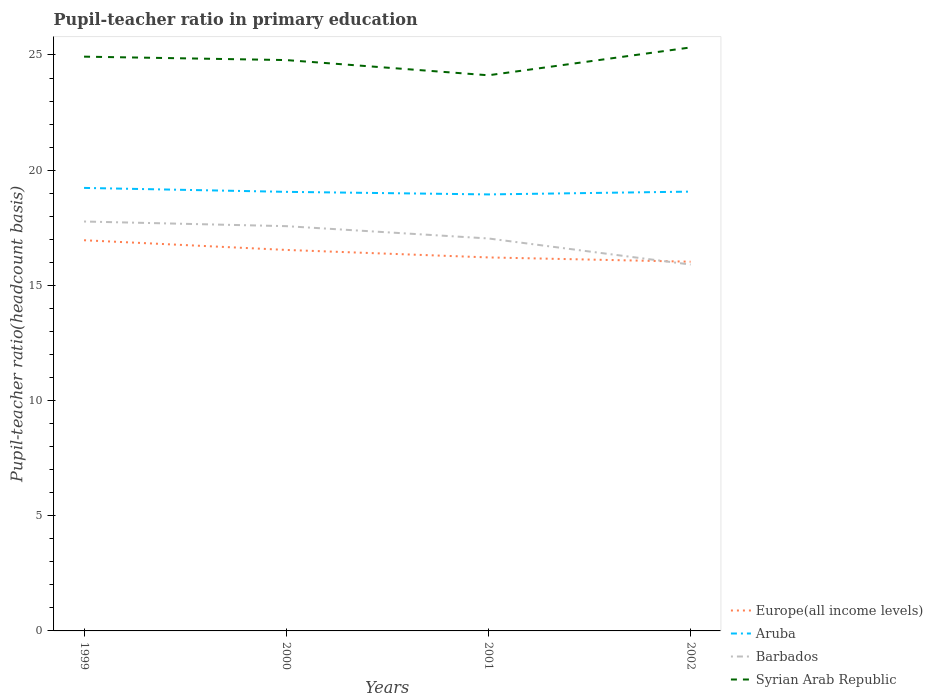How many different coloured lines are there?
Provide a short and direct response. 4. Across all years, what is the maximum pupil-teacher ratio in primary education in Europe(all income levels)?
Ensure brevity in your answer.  16.03. In which year was the pupil-teacher ratio in primary education in Aruba maximum?
Provide a succinct answer. 2001. What is the total pupil-teacher ratio in primary education in Barbados in the graph?
Ensure brevity in your answer.  1.67. What is the difference between the highest and the second highest pupil-teacher ratio in primary education in Syrian Arab Republic?
Provide a short and direct response. 1.21. What is the difference between the highest and the lowest pupil-teacher ratio in primary education in Syrian Arab Republic?
Make the answer very short. 2. How many years are there in the graph?
Make the answer very short. 4. Are the values on the major ticks of Y-axis written in scientific E-notation?
Keep it short and to the point. No. Does the graph contain grids?
Give a very brief answer. No. Where does the legend appear in the graph?
Offer a terse response. Bottom right. How are the legend labels stacked?
Ensure brevity in your answer.  Vertical. What is the title of the graph?
Give a very brief answer. Pupil-teacher ratio in primary education. What is the label or title of the Y-axis?
Offer a terse response. Pupil-teacher ratio(headcount basis). What is the Pupil-teacher ratio(headcount basis) in Europe(all income levels) in 1999?
Give a very brief answer. 16.96. What is the Pupil-teacher ratio(headcount basis) of Aruba in 1999?
Keep it short and to the point. 19.23. What is the Pupil-teacher ratio(headcount basis) of Barbados in 1999?
Your response must be concise. 17.77. What is the Pupil-teacher ratio(headcount basis) in Syrian Arab Republic in 1999?
Your response must be concise. 24.93. What is the Pupil-teacher ratio(headcount basis) in Europe(all income levels) in 2000?
Your response must be concise. 16.54. What is the Pupil-teacher ratio(headcount basis) of Aruba in 2000?
Provide a short and direct response. 19.06. What is the Pupil-teacher ratio(headcount basis) in Barbados in 2000?
Your answer should be very brief. 17.57. What is the Pupil-teacher ratio(headcount basis) of Syrian Arab Republic in 2000?
Make the answer very short. 24.78. What is the Pupil-teacher ratio(headcount basis) of Europe(all income levels) in 2001?
Provide a short and direct response. 16.21. What is the Pupil-teacher ratio(headcount basis) of Aruba in 2001?
Offer a terse response. 18.95. What is the Pupil-teacher ratio(headcount basis) in Barbados in 2001?
Your response must be concise. 17.04. What is the Pupil-teacher ratio(headcount basis) of Syrian Arab Republic in 2001?
Offer a terse response. 24.12. What is the Pupil-teacher ratio(headcount basis) of Europe(all income levels) in 2002?
Provide a short and direct response. 16.03. What is the Pupil-teacher ratio(headcount basis) in Aruba in 2002?
Keep it short and to the point. 19.07. What is the Pupil-teacher ratio(headcount basis) of Barbados in 2002?
Offer a terse response. 15.9. What is the Pupil-teacher ratio(headcount basis) in Syrian Arab Republic in 2002?
Your answer should be compact. 25.33. Across all years, what is the maximum Pupil-teacher ratio(headcount basis) in Europe(all income levels)?
Provide a short and direct response. 16.96. Across all years, what is the maximum Pupil-teacher ratio(headcount basis) in Aruba?
Your answer should be very brief. 19.23. Across all years, what is the maximum Pupil-teacher ratio(headcount basis) of Barbados?
Your answer should be very brief. 17.77. Across all years, what is the maximum Pupil-teacher ratio(headcount basis) in Syrian Arab Republic?
Your answer should be very brief. 25.33. Across all years, what is the minimum Pupil-teacher ratio(headcount basis) in Europe(all income levels)?
Make the answer very short. 16.03. Across all years, what is the minimum Pupil-teacher ratio(headcount basis) in Aruba?
Give a very brief answer. 18.95. Across all years, what is the minimum Pupil-teacher ratio(headcount basis) of Barbados?
Offer a very short reply. 15.9. Across all years, what is the minimum Pupil-teacher ratio(headcount basis) of Syrian Arab Republic?
Keep it short and to the point. 24.12. What is the total Pupil-teacher ratio(headcount basis) in Europe(all income levels) in the graph?
Ensure brevity in your answer.  65.74. What is the total Pupil-teacher ratio(headcount basis) of Aruba in the graph?
Your answer should be compact. 76.31. What is the total Pupil-teacher ratio(headcount basis) in Barbados in the graph?
Provide a short and direct response. 68.28. What is the total Pupil-teacher ratio(headcount basis) of Syrian Arab Republic in the graph?
Provide a succinct answer. 99.16. What is the difference between the Pupil-teacher ratio(headcount basis) of Europe(all income levels) in 1999 and that in 2000?
Provide a short and direct response. 0.42. What is the difference between the Pupil-teacher ratio(headcount basis) of Aruba in 1999 and that in 2000?
Provide a short and direct response. 0.17. What is the difference between the Pupil-teacher ratio(headcount basis) of Barbados in 1999 and that in 2000?
Make the answer very short. 0.2. What is the difference between the Pupil-teacher ratio(headcount basis) in Syrian Arab Republic in 1999 and that in 2000?
Offer a terse response. 0.15. What is the difference between the Pupil-teacher ratio(headcount basis) in Europe(all income levels) in 1999 and that in 2001?
Offer a very short reply. 0.75. What is the difference between the Pupil-teacher ratio(headcount basis) of Aruba in 1999 and that in 2001?
Keep it short and to the point. 0.28. What is the difference between the Pupil-teacher ratio(headcount basis) in Barbados in 1999 and that in 2001?
Give a very brief answer. 0.74. What is the difference between the Pupil-teacher ratio(headcount basis) in Syrian Arab Republic in 1999 and that in 2001?
Your answer should be compact. 0.81. What is the difference between the Pupil-teacher ratio(headcount basis) of Europe(all income levels) in 1999 and that in 2002?
Your answer should be very brief. 0.93. What is the difference between the Pupil-teacher ratio(headcount basis) of Aruba in 1999 and that in 2002?
Give a very brief answer. 0.16. What is the difference between the Pupil-teacher ratio(headcount basis) in Barbados in 1999 and that in 2002?
Your response must be concise. 1.87. What is the difference between the Pupil-teacher ratio(headcount basis) of Syrian Arab Republic in 1999 and that in 2002?
Your response must be concise. -0.4. What is the difference between the Pupil-teacher ratio(headcount basis) of Europe(all income levels) in 2000 and that in 2001?
Your answer should be very brief. 0.32. What is the difference between the Pupil-teacher ratio(headcount basis) in Aruba in 2000 and that in 2001?
Your answer should be compact. 0.11. What is the difference between the Pupil-teacher ratio(headcount basis) of Barbados in 2000 and that in 2001?
Ensure brevity in your answer.  0.53. What is the difference between the Pupil-teacher ratio(headcount basis) in Syrian Arab Republic in 2000 and that in 2001?
Give a very brief answer. 0.66. What is the difference between the Pupil-teacher ratio(headcount basis) of Europe(all income levels) in 2000 and that in 2002?
Your answer should be very brief. 0.51. What is the difference between the Pupil-teacher ratio(headcount basis) in Aruba in 2000 and that in 2002?
Your answer should be very brief. -0.01. What is the difference between the Pupil-teacher ratio(headcount basis) of Barbados in 2000 and that in 2002?
Ensure brevity in your answer.  1.67. What is the difference between the Pupil-teacher ratio(headcount basis) of Syrian Arab Republic in 2000 and that in 2002?
Your answer should be compact. -0.55. What is the difference between the Pupil-teacher ratio(headcount basis) in Europe(all income levels) in 2001 and that in 2002?
Provide a short and direct response. 0.19. What is the difference between the Pupil-teacher ratio(headcount basis) in Aruba in 2001 and that in 2002?
Your answer should be compact. -0.12. What is the difference between the Pupil-teacher ratio(headcount basis) in Barbados in 2001 and that in 2002?
Provide a succinct answer. 1.13. What is the difference between the Pupil-teacher ratio(headcount basis) in Syrian Arab Republic in 2001 and that in 2002?
Your answer should be very brief. -1.21. What is the difference between the Pupil-teacher ratio(headcount basis) of Europe(all income levels) in 1999 and the Pupil-teacher ratio(headcount basis) of Aruba in 2000?
Give a very brief answer. -2.1. What is the difference between the Pupil-teacher ratio(headcount basis) of Europe(all income levels) in 1999 and the Pupil-teacher ratio(headcount basis) of Barbados in 2000?
Offer a very short reply. -0.61. What is the difference between the Pupil-teacher ratio(headcount basis) of Europe(all income levels) in 1999 and the Pupil-teacher ratio(headcount basis) of Syrian Arab Republic in 2000?
Make the answer very short. -7.82. What is the difference between the Pupil-teacher ratio(headcount basis) of Aruba in 1999 and the Pupil-teacher ratio(headcount basis) of Barbados in 2000?
Offer a very short reply. 1.66. What is the difference between the Pupil-teacher ratio(headcount basis) in Aruba in 1999 and the Pupil-teacher ratio(headcount basis) in Syrian Arab Republic in 2000?
Ensure brevity in your answer.  -5.55. What is the difference between the Pupil-teacher ratio(headcount basis) in Barbados in 1999 and the Pupil-teacher ratio(headcount basis) in Syrian Arab Republic in 2000?
Ensure brevity in your answer.  -7.01. What is the difference between the Pupil-teacher ratio(headcount basis) of Europe(all income levels) in 1999 and the Pupil-teacher ratio(headcount basis) of Aruba in 2001?
Your answer should be compact. -1.99. What is the difference between the Pupil-teacher ratio(headcount basis) in Europe(all income levels) in 1999 and the Pupil-teacher ratio(headcount basis) in Barbados in 2001?
Your response must be concise. -0.08. What is the difference between the Pupil-teacher ratio(headcount basis) of Europe(all income levels) in 1999 and the Pupil-teacher ratio(headcount basis) of Syrian Arab Republic in 2001?
Ensure brevity in your answer.  -7.16. What is the difference between the Pupil-teacher ratio(headcount basis) in Aruba in 1999 and the Pupil-teacher ratio(headcount basis) in Barbados in 2001?
Make the answer very short. 2.19. What is the difference between the Pupil-teacher ratio(headcount basis) in Aruba in 1999 and the Pupil-teacher ratio(headcount basis) in Syrian Arab Republic in 2001?
Offer a very short reply. -4.89. What is the difference between the Pupil-teacher ratio(headcount basis) of Barbados in 1999 and the Pupil-teacher ratio(headcount basis) of Syrian Arab Republic in 2001?
Make the answer very short. -6.35. What is the difference between the Pupil-teacher ratio(headcount basis) in Europe(all income levels) in 1999 and the Pupil-teacher ratio(headcount basis) in Aruba in 2002?
Your answer should be compact. -2.11. What is the difference between the Pupil-teacher ratio(headcount basis) of Europe(all income levels) in 1999 and the Pupil-teacher ratio(headcount basis) of Barbados in 2002?
Provide a short and direct response. 1.06. What is the difference between the Pupil-teacher ratio(headcount basis) in Europe(all income levels) in 1999 and the Pupil-teacher ratio(headcount basis) in Syrian Arab Republic in 2002?
Your response must be concise. -8.37. What is the difference between the Pupil-teacher ratio(headcount basis) in Aruba in 1999 and the Pupil-teacher ratio(headcount basis) in Barbados in 2002?
Provide a succinct answer. 3.33. What is the difference between the Pupil-teacher ratio(headcount basis) in Aruba in 1999 and the Pupil-teacher ratio(headcount basis) in Syrian Arab Republic in 2002?
Your answer should be compact. -6.1. What is the difference between the Pupil-teacher ratio(headcount basis) of Barbados in 1999 and the Pupil-teacher ratio(headcount basis) of Syrian Arab Republic in 2002?
Ensure brevity in your answer.  -7.56. What is the difference between the Pupil-teacher ratio(headcount basis) of Europe(all income levels) in 2000 and the Pupil-teacher ratio(headcount basis) of Aruba in 2001?
Your answer should be compact. -2.41. What is the difference between the Pupil-teacher ratio(headcount basis) in Europe(all income levels) in 2000 and the Pupil-teacher ratio(headcount basis) in Barbados in 2001?
Keep it short and to the point. -0.5. What is the difference between the Pupil-teacher ratio(headcount basis) in Europe(all income levels) in 2000 and the Pupil-teacher ratio(headcount basis) in Syrian Arab Republic in 2001?
Give a very brief answer. -7.58. What is the difference between the Pupil-teacher ratio(headcount basis) of Aruba in 2000 and the Pupil-teacher ratio(headcount basis) of Barbados in 2001?
Offer a very short reply. 2.02. What is the difference between the Pupil-teacher ratio(headcount basis) of Aruba in 2000 and the Pupil-teacher ratio(headcount basis) of Syrian Arab Republic in 2001?
Keep it short and to the point. -5.06. What is the difference between the Pupil-teacher ratio(headcount basis) in Barbados in 2000 and the Pupil-teacher ratio(headcount basis) in Syrian Arab Republic in 2001?
Provide a succinct answer. -6.55. What is the difference between the Pupil-teacher ratio(headcount basis) in Europe(all income levels) in 2000 and the Pupil-teacher ratio(headcount basis) in Aruba in 2002?
Keep it short and to the point. -2.53. What is the difference between the Pupil-teacher ratio(headcount basis) of Europe(all income levels) in 2000 and the Pupil-teacher ratio(headcount basis) of Barbados in 2002?
Your answer should be very brief. 0.63. What is the difference between the Pupil-teacher ratio(headcount basis) in Europe(all income levels) in 2000 and the Pupil-teacher ratio(headcount basis) in Syrian Arab Republic in 2002?
Offer a very short reply. -8.79. What is the difference between the Pupil-teacher ratio(headcount basis) in Aruba in 2000 and the Pupil-teacher ratio(headcount basis) in Barbados in 2002?
Make the answer very short. 3.16. What is the difference between the Pupil-teacher ratio(headcount basis) in Aruba in 2000 and the Pupil-teacher ratio(headcount basis) in Syrian Arab Republic in 2002?
Offer a very short reply. -6.27. What is the difference between the Pupil-teacher ratio(headcount basis) of Barbados in 2000 and the Pupil-teacher ratio(headcount basis) of Syrian Arab Republic in 2002?
Keep it short and to the point. -7.76. What is the difference between the Pupil-teacher ratio(headcount basis) of Europe(all income levels) in 2001 and the Pupil-teacher ratio(headcount basis) of Aruba in 2002?
Keep it short and to the point. -2.86. What is the difference between the Pupil-teacher ratio(headcount basis) of Europe(all income levels) in 2001 and the Pupil-teacher ratio(headcount basis) of Barbados in 2002?
Keep it short and to the point. 0.31. What is the difference between the Pupil-teacher ratio(headcount basis) of Europe(all income levels) in 2001 and the Pupil-teacher ratio(headcount basis) of Syrian Arab Republic in 2002?
Provide a succinct answer. -9.12. What is the difference between the Pupil-teacher ratio(headcount basis) of Aruba in 2001 and the Pupil-teacher ratio(headcount basis) of Barbados in 2002?
Your response must be concise. 3.04. What is the difference between the Pupil-teacher ratio(headcount basis) of Aruba in 2001 and the Pupil-teacher ratio(headcount basis) of Syrian Arab Republic in 2002?
Keep it short and to the point. -6.38. What is the difference between the Pupil-teacher ratio(headcount basis) of Barbados in 2001 and the Pupil-teacher ratio(headcount basis) of Syrian Arab Republic in 2002?
Keep it short and to the point. -8.29. What is the average Pupil-teacher ratio(headcount basis) of Europe(all income levels) per year?
Your response must be concise. 16.43. What is the average Pupil-teacher ratio(headcount basis) in Aruba per year?
Keep it short and to the point. 19.08. What is the average Pupil-teacher ratio(headcount basis) of Barbados per year?
Offer a very short reply. 17.07. What is the average Pupil-teacher ratio(headcount basis) of Syrian Arab Republic per year?
Your answer should be compact. 24.79. In the year 1999, what is the difference between the Pupil-teacher ratio(headcount basis) of Europe(all income levels) and Pupil-teacher ratio(headcount basis) of Aruba?
Offer a terse response. -2.27. In the year 1999, what is the difference between the Pupil-teacher ratio(headcount basis) in Europe(all income levels) and Pupil-teacher ratio(headcount basis) in Barbados?
Make the answer very short. -0.81. In the year 1999, what is the difference between the Pupil-teacher ratio(headcount basis) of Europe(all income levels) and Pupil-teacher ratio(headcount basis) of Syrian Arab Republic?
Give a very brief answer. -7.97. In the year 1999, what is the difference between the Pupil-teacher ratio(headcount basis) of Aruba and Pupil-teacher ratio(headcount basis) of Barbados?
Your answer should be compact. 1.46. In the year 1999, what is the difference between the Pupil-teacher ratio(headcount basis) in Aruba and Pupil-teacher ratio(headcount basis) in Syrian Arab Republic?
Give a very brief answer. -5.7. In the year 1999, what is the difference between the Pupil-teacher ratio(headcount basis) in Barbados and Pupil-teacher ratio(headcount basis) in Syrian Arab Republic?
Make the answer very short. -7.16. In the year 2000, what is the difference between the Pupil-teacher ratio(headcount basis) in Europe(all income levels) and Pupil-teacher ratio(headcount basis) in Aruba?
Provide a succinct answer. -2.52. In the year 2000, what is the difference between the Pupil-teacher ratio(headcount basis) in Europe(all income levels) and Pupil-teacher ratio(headcount basis) in Barbados?
Offer a very short reply. -1.03. In the year 2000, what is the difference between the Pupil-teacher ratio(headcount basis) in Europe(all income levels) and Pupil-teacher ratio(headcount basis) in Syrian Arab Republic?
Provide a succinct answer. -8.24. In the year 2000, what is the difference between the Pupil-teacher ratio(headcount basis) of Aruba and Pupil-teacher ratio(headcount basis) of Barbados?
Offer a terse response. 1.49. In the year 2000, what is the difference between the Pupil-teacher ratio(headcount basis) of Aruba and Pupil-teacher ratio(headcount basis) of Syrian Arab Republic?
Your answer should be compact. -5.72. In the year 2000, what is the difference between the Pupil-teacher ratio(headcount basis) of Barbados and Pupil-teacher ratio(headcount basis) of Syrian Arab Republic?
Offer a very short reply. -7.21. In the year 2001, what is the difference between the Pupil-teacher ratio(headcount basis) of Europe(all income levels) and Pupil-teacher ratio(headcount basis) of Aruba?
Make the answer very short. -2.73. In the year 2001, what is the difference between the Pupil-teacher ratio(headcount basis) of Europe(all income levels) and Pupil-teacher ratio(headcount basis) of Barbados?
Offer a terse response. -0.82. In the year 2001, what is the difference between the Pupil-teacher ratio(headcount basis) of Europe(all income levels) and Pupil-teacher ratio(headcount basis) of Syrian Arab Republic?
Your answer should be compact. -7.91. In the year 2001, what is the difference between the Pupil-teacher ratio(headcount basis) in Aruba and Pupil-teacher ratio(headcount basis) in Barbados?
Your answer should be very brief. 1.91. In the year 2001, what is the difference between the Pupil-teacher ratio(headcount basis) in Aruba and Pupil-teacher ratio(headcount basis) in Syrian Arab Republic?
Make the answer very short. -5.17. In the year 2001, what is the difference between the Pupil-teacher ratio(headcount basis) in Barbados and Pupil-teacher ratio(headcount basis) in Syrian Arab Republic?
Provide a short and direct response. -7.08. In the year 2002, what is the difference between the Pupil-teacher ratio(headcount basis) in Europe(all income levels) and Pupil-teacher ratio(headcount basis) in Aruba?
Ensure brevity in your answer.  -3.04. In the year 2002, what is the difference between the Pupil-teacher ratio(headcount basis) in Europe(all income levels) and Pupil-teacher ratio(headcount basis) in Barbados?
Offer a terse response. 0.12. In the year 2002, what is the difference between the Pupil-teacher ratio(headcount basis) of Europe(all income levels) and Pupil-teacher ratio(headcount basis) of Syrian Arab Republic?
Ensure brevity in your answer.  -9.3. In the year 2002, what is the difference between the Pupil-teacher ratio(headcount basis) of Aruba and Pupil-teacher ratio(headcount basis) of Barbados?
Offer a terse response. 3.17. In the year 2002, what is the difference between the Pupil-teacher ratio(headcount basis) in Aruba and Pupil-teacher ratio(headcount basis) in Syrian Arab Republic?
Give a very brief answer. -6.26. In the year 2002, what is the difference between the Pupil-teacher ratio(headcount basis) in Barbados and Pupil-teacher ratio(headcount basis) in Syrian Arab Republic?
Keep it short and to the point. -9.43. What is the ratio of the Pupil-teacher ratio(headcount basis) in Europe(all income levels) in 1999 to that in 2000?
Offer a terse response. 1.03. What is the ratio of the Pupil-teacher ratio(headcount basis) of Barbados in 1999 to that in 2000?
Provide a short and direct response. 1.01. What is the ratio of the Pupil-teacher ratio(headcount basis) in Europe(all income levels) in 1999 to that in 2001?
Your answer should be very brief. 1.05. What is the ratio of the Pupil-teacher ratio(headcount basis) of Aruba in 1999 to that in 2001?
Offer a very short reply. 1.01. What is the ratio of the Pupil-teacher ratio(headcount basis) of Barbados in 1999 to that in 2001?
Offer a very short reply. 1.04. What is the ratio of the Pupil-teacher ratio(headcount basis) of Syrian Arab Republic in 1999 to that in 2001?
Ensure brevity in your answer.  1.03. What is the ratio of the Pupil-teacher ratio(headcount basis) of Europe(all income levels) in 1999 to that in 2002?
Your answer should be very brief. 1.06. What is the ratio of the Pupil-teacher ratio(headcount basis) of Aruba in 1999 to that in 2002?
Your answer should be very brief. 1.01. What is the ratio of the Pupil-teacher ratio(headcount basis) of Barbados in 1999 to that in 2002?
Your response must be concise. 1.12. What is the ratio of the Pupil-teacher ratio(headcount basis) of Syrian Arab Republic in 1999 to that in 2002?
Offer a very short reply. 0.98. What is the ratio of the Pupil-teacher ratio(headcount basis) in Aruba in 2000 to that in 2001?
Offer a terse response. 1.01. What is the ratio of the Pupil-teacher ratio(headcount basis) of Barbados in 2000 to that in 2001?
Make the answer very short. 1.03. What is the ratio of the Pupil-teacher ratio(headcount basis) of Syrian Arab Republic in 2000 to that in 2001?
Your response must be concise. 1.03. What is the ratio of the Pupil-teacher ratio(headcount basis) of Europe(all income levels) in 2000 to that in 2002?
Keep it short and to the point. 1.03. What is the ratio of the Pupil-teacher ratio(headcount basis) of Barbados in 2000 to that in 2002?
Your answer should be compact. 1.1. What is the ratio of the Pupil-teacher ratio(headcount basis) in Syrian Arab Republic in 2000 to that in 2002?
Make the answer very short. 0.98. What is the ratio of the Pupil-teacher ratio(headcount basis) of Europe(all income levels) in 2001 to that in 2002?
Your response must be concise. 1.01. What is the ratio of the Pupil-teacher ratio(headcount basis) in Aruba in 2001 to that in 2002?
Your answer should be very brief. 0.99. What is the ratio of the Pupil-teacher ratio(headcount basis) in Barbados in 2001 to that in 2002?
Give a very brief answer. 1.07. What is the ratio of the Pupil-teacher ratio(headcount basis) of Syrian Arab Republic in 2001 to that in 2002?
Provide a succinct answer. 0.95. What is the difference between the highest and the second highest Pupil-teacher ratio(headcount basis) of Europe(all income levels)?
Ensure brevity in your answer.  0.42. What is the difference between the highest and the second highest Pupil-teacher ratio(headcount basis) in Aruba?
Give a very brief answer. 0.16. What is the difference between the highest and the second highest Pupil-teacher ratio(headcount basis) in Barbados?
Your answer should be compact. 0.2. What is the difference between the highest and the second highest Pupil-teacher ratio(headcount basis) of Syrian Arab Republic?
Your answer should be very brief. 0.4. What is the difference between the highest and the lowest Pupil-teacher ratio(headcount basis) of Europe(all income levels)?
Offer a terse response. 0.93. What is the difference between the highest and the lowest Pupil-teacher ratio(headcount basis) of Aruba?
Provide a succinct answer. 0.28. What is the difference between the highest and the lowest Pupil-teacher ratio(headcount basis) in Barbados?
Make the answer very short. 1.87. What is the difference between the highest and the lowest Pupil-teacher ratio(headcount basis) of Syrian Arab Republic?
Your response must be concise. 1.21. 